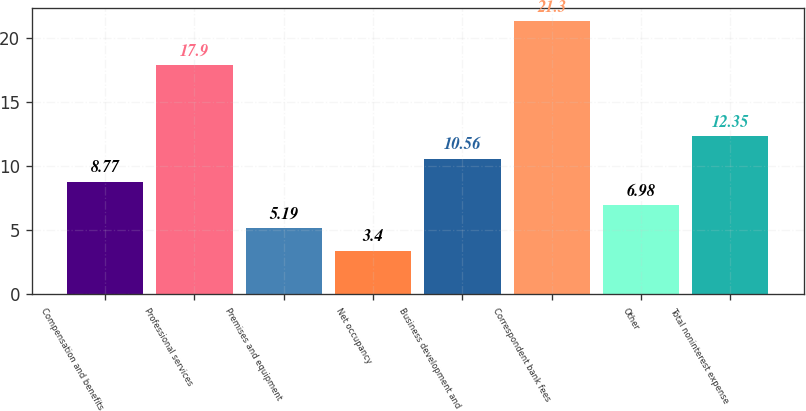<chart> <loc_0><loc_0><loc_500><loc_500><bar_chart><fcel>Compensation and benefits<fcel>Professional services<fcel>Premises and equipment<fcel>Net occupancy<fcel>Business development and<fcel>Correspondent bank fees<fcel>Other<fcel>Total noninterest expense<nl><fcel>8.77<fcel>17.9<fcel>5.19<fcel>3.4<fcel>10.56<fcel>21.3<fcel>6.98<fcel>12.35<nl></chart> 